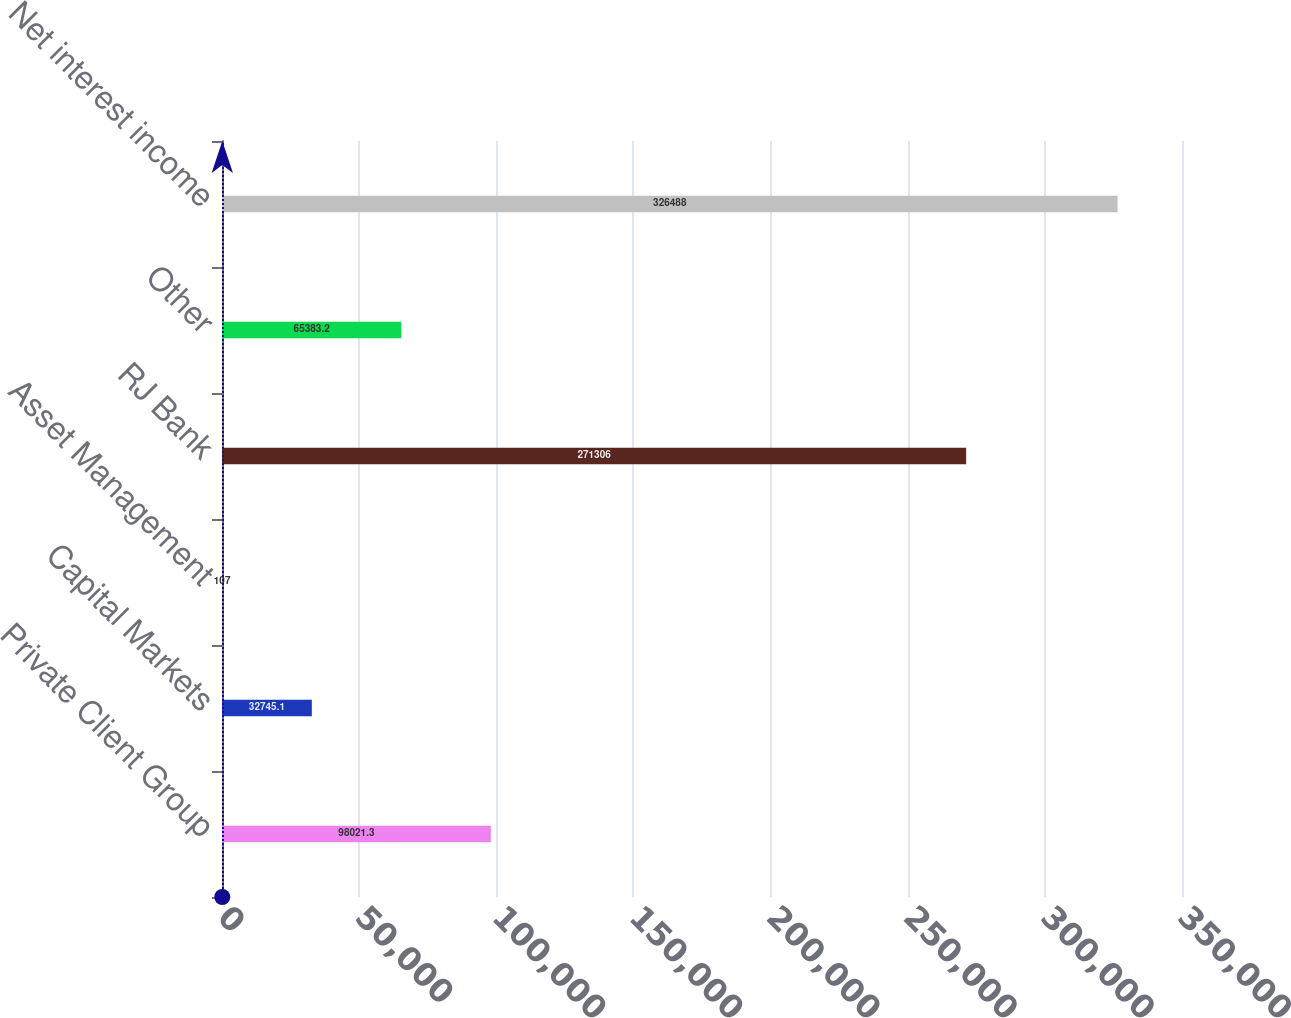Convert chart to OTSL. <chart><loc_0><loc_0><loc_500><loc_500><bar_chart><fcel>Private Client Group<fcel>Capital Markets<fcel>Asset Management<fcel>RJ Bank<fcel>Other<fcel>Net interest income<nl><fcel>98021.3<fcel>32745.1<fcel>107<fcel>271306<fcel>65383.2<fcel>326488<nl></chart> 